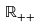Convert formula to latex. <formula><loc_0><loc_0><loc_500><loc_500>\mathbb { R } _ { + + }</formula> 